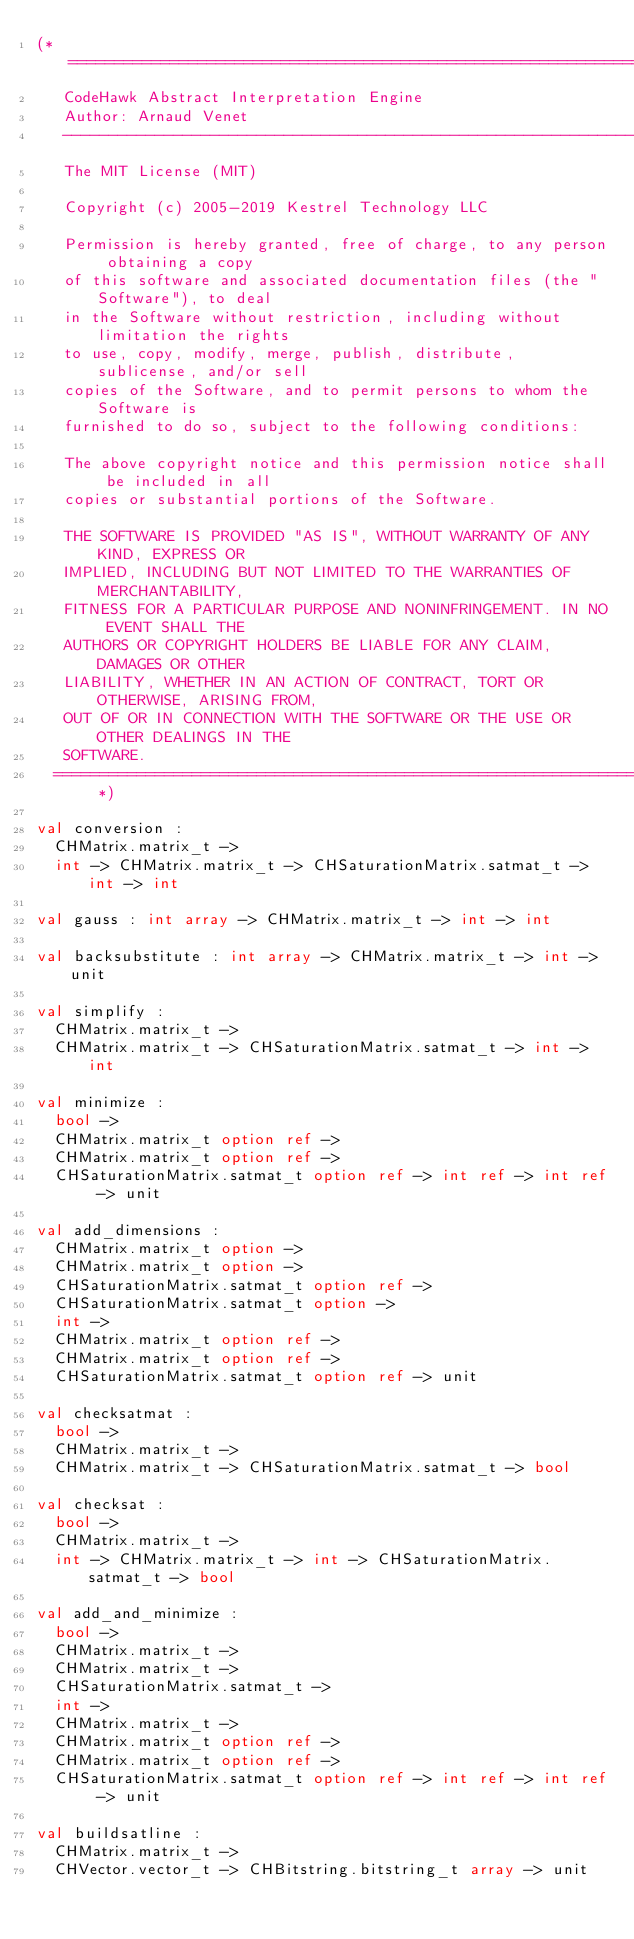<code> <loc_0><loc_0><loc_500><loc_500><_OCaml_>(* =============================================================================
   CodeHawk Abstract Interpretation Engine
   Author: Arnaud Venet
   -----------------------------------------------------------------------------
   The MIT License (MIT)
 
   Copyright (c) 2005-2019 Kestrel Technology LLC

   Permission is hereby granted, free of charge, to any person obtaining a copy
   of this software and associated documentation files (the "Software"), to deal
   in the Software without restriction, including without limitation the rights
   to use, copy, modify, merge, publish, distribute, sublicense, and/or sell
   copies of the Software, and to permit persons to whom the Software is
   furnished to do so, subject to the following conditions:
 
   The above copyright notice and this permission notice shall be included in all
   copies or substantial portions of the Software.
  
   THE SOFTWARE IS PROVIDED "AS IS", WITHOUT WARRANTY OF ANY KIND, EXPRESS OR
   IMPLIED, INCLUDING BUT NOT LIMITED TO THE WARRANTIES OF MERCHANTABILITY,
   FITNESS FOR A PARTICULAR PURPOSE AND NONINFRINGEMENT. IN NO EVENT SHALL THE
   AUTHORS OR COPYRIGHT HOLDERS BE LIABLE FOR ANY CLAIM, DAMAGES OR OTHER
   LIABILITY, WHETHER IN AN ACTION OF CONTRACT, TORT OR OTHERWISE, ARISING FROM,
   OUT OF OR IN CONNECTION WITH THE SOFTWARE OR THE USE OR OTHER DEALINGS IN THE
   SOFTWARE.
  ============================================================================== *)

val conversion :
  CHMatrix.matrix_t ->
  int -> CHMatrix.matrix_t -> CHSaturationMatrix.satmat_t -> int -> int

val gauss : int array -> CHMatrix.matrix_t -> int -> int

val backsubstitute : int array -> CHMatrix.matrix_t -> int -> unit

val simplify :
  CHMatrix.matrix_t ->
  CHMatrix.matrix_t -> CHSaturationMatrix.satmat_t -> int -> int

val minimize :
  bool ->
  CHMatrix.matrix_t option ref ->
  CHMatrix.matrix_t option ref ->
  CHSaturationMatrix.satmat_t option ref -> int ref -> int ref -> unit

val add_dimensions :
  CHMatrix.matrix_t option ->
  CHMatrix.matrix_t option ->
  CHSaturationMatrix.satmat_t option ref ->
  CHSaturationMatrix.satmat_t option ->
  int ->
  CHMatrix.matrix_t option ref ->
  CHMatrix.matrix_t option ref ->
  CHSaturationMatrix.satmat_t option ref -> unit

val checksatmat :
  bool ->
  CHMatrix.matrix_t ->
  CHMatrix.matrix_t -> CHSaturationMatrix.satmat_t -> bool

val checksat :
  bool ->
  CHMatrix.matrix_t ->
  int -> CHMatrix.matrix_t -> int -> CHSaturationMatrix.satmat_t -> bool

val add_and_minimize :
  bool ->
  CHMatrix.matrix_t ->
  CHMatrix.matrix_t ->
  CHSaturationMatrix.satmat_t ->
  int ->
  CHMatrix.matrix_t ->
  CHMatrix.matrix_t option ref ->
  CHMatrix.matrix_t option ref ->
  CHSaturationMatrix.satmat_t option ref -> int ref -> int ref -> unit

val buildsatline :
  CHMatrix.matrix_t ->
  CHVector.vector_t -> CHBitstring.bitstring_t array -> unit
</code> 